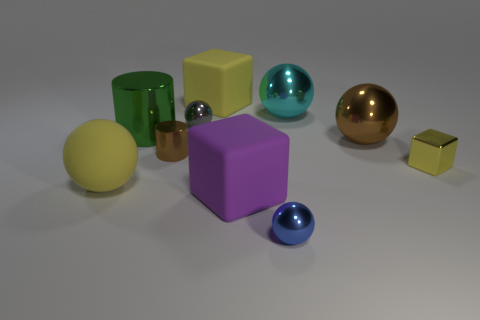How many cylinders are either big purple things or cyan objects?
Make the answer very short. 0. How many green shiny cylinders are behind the matte object that is behind the tiny shiny sphere that is behind the large purple rubber object?
Make the answer very short. 0. Do the small blue shiny object and the gray thing have the same shape?
Make the answer very short. Yes. Is the big yellow thing that is left of the green object made of the same material as the blue sphere in front of the small brown metallic cylinder?
Provide a short and direct response. No. What number of things are either metal balls behind the yellow metallic object or matte cubes that are behind the large brown ball?
Offer a very short reply. 4. How many small cylinders are there?
Provide a short and direct response. 1. Is there a cyan shiny cube of the same size as the green cylinder?
Provide a short and direct response. No. Does the blue thing have the same material as the yellow object that is in front of the small block?
Give a very brief answer. No. There is a cube that is behind the tiny shiny cylinder; what material is it?
Make the answer very short. Rubber. The shiny cube is what size?
Make the answer very short. Small. 